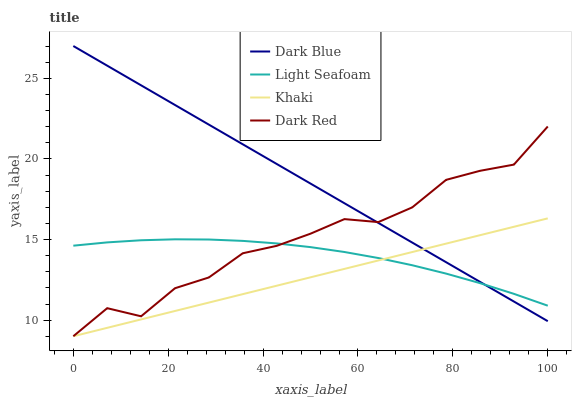Does Khaki have the minimum area under the curve?
Answer yes or no. Yes. Does Dark Blue have the maximum area under the curve?
Answer yes or no. Yes. Does Light Seafoam have the minimum area under the curve?
Answer yes or no. No. Does Light Seafoam have the maximum area under the curve?
Answer yes or no. No. Is Khaki the smoothest?
Answer yes or no. Yes. Is Dark Red the roughest?
Answer yes or no. Yes. Is Light Seafoam the smoothest?
Answer yes or no. No. Is Light Seafoam the roughest?
Answer yes or no. No. Does Light Seafoam have the lowest value?
Answer yes or no. No. Does Khaki have the highest value?
Answer yes or no. No. Is Khaki less than Dark Red?
Answer yes or no. Yes. Is Dark Red greater than Khaki?
Answer yes or no. Yes. Does Khaki intersect Dark Red?
Answer yes or no. No. 